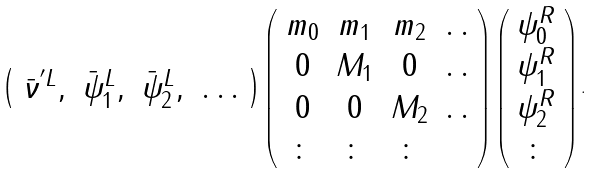<formula> <loc_0><loc_0><loc_500><loc_500>\left ( \begin{array} { c c c c } \bar { \nu } ^ { ^ { \prime } L } , & \bar { \psi } _ { 1 } ^ { L } , & \bar { \psi } _ { 2 } ^ { L } , & \dots \end{array} \right ) \left ( \begin{array} { c c c c } m _ { 0 } & m _ { 1 } & m _ { 2 } & . \, . \\ 0 & M _ { 1 } & 0 & . \, . \\ 0 & 0 & M _ { 2 } & . \, . \\ \colon & \colon & \colon & \end{array} \right ) \left ( \begin{array} { c } \psi _ { 0 } ^ { R } \\ \psi _ { 1 } ^ { R } \\ \psi _ { 2 } ^ { R } \\ \colon \end{array} \right ) .</formula> 